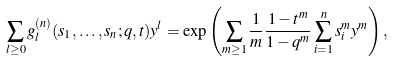Convert formula to latex. <formula><loc_0><loc_0><loc_500><loc_500>\sum _ { l \geq 0 } g _ { l } ^ { ( n ) } ( s _ { 1 } , \dots , s _ { n } ; q , t ) y ^ { l } = \exp \left ( \sum _ { m \geq 1 } \frac { 1 } { m } \frac { 1 - t ^ { m } } { 1 - q ^ { m } } \sum _ { i = 1 } ^ { n } s _ { i } ^ { m } y ^ { m } \right ) ,</formula> 